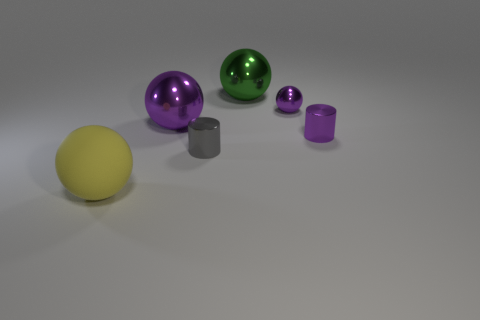How many cylinders are right of the small cylinder that is on the left side of the large green sphere? 1 